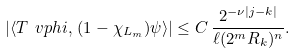Convert formula to latex. <formula><loc_0><loc_0><loc_500><loc_500>| \langle T \ v p h i , \, ( 1 - \chi _ { L _ { m } } ) \psi \rangle | \leq C \, \frac { 2 ^ { - \nu | j - k | } } { \ell ( 2 ^ { m } R _ { k } ) ^ { n } } .</formula> 